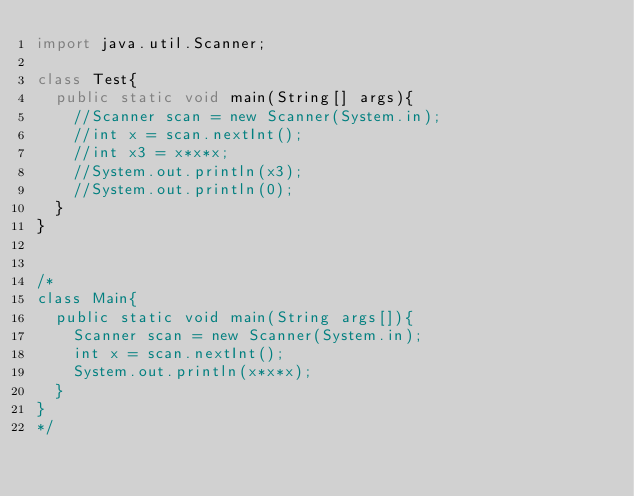<code> <loc_0><loc_0><loc_500><loc_500><_Java_>import java.util.Scanner;

class Test{
  public static void main(String[] args){
    //Scanner scan = new Scanner(System.in);
    //int x = scan.nextInt();
    //int x3 = x*x*x;
    //System.out.println(x3);
    //System.out.println(0);
  }
}


/*
class Main{
  public static void main(String args[]){
    Scanner scan = new Scanner(System.in);
    int x = scan.nextInt();
    System.out.println(x*x*x);
  }
}
*/
</code> 